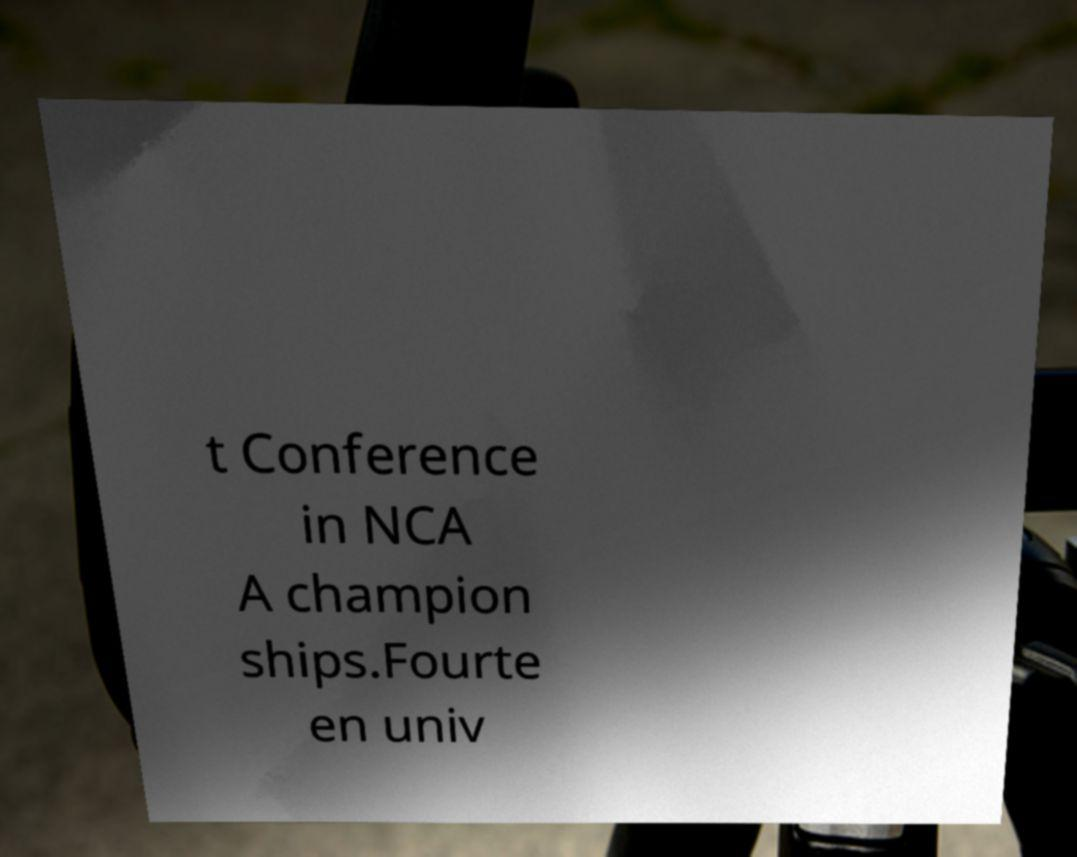Can you read and provide the text displayed in the image?This photo seems to have some interesting text. Can you extract and type it out for me? t Conference in NCA A champion ships.Fourte en univ 